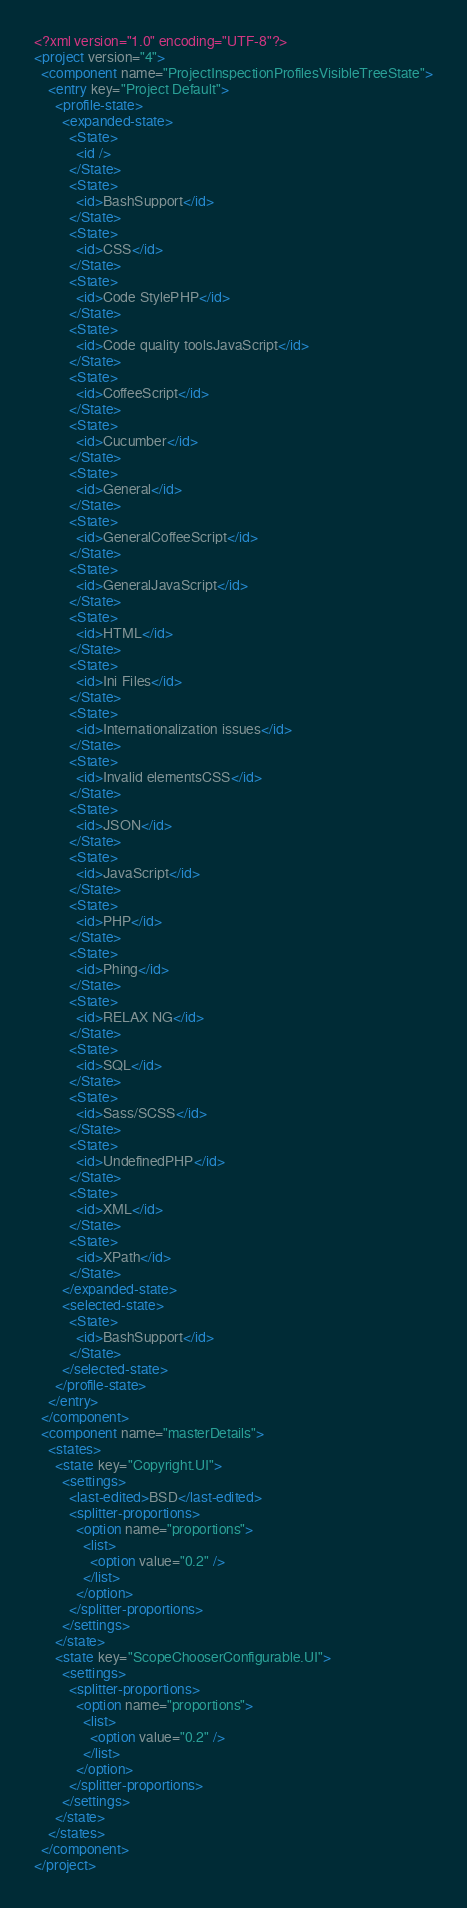Convert code to text. <code><loc_0><loc_0><loc_500><loc_500><_XML_><?xml version="1.0" encoding="UTF-8"?>
<project version="4">
  <component name="ProjectInspectionProfilesVisibleTreeState">
    <entry key="Project Default">
      <profile-state>
        <expanded-state>
          <State>
            <id />
          </State>
          <State>
            <id>BashSupport</id>
          </State>
          <State>
            <id>CSS</id>
          </State>
          <State>
            <id>Code StylePHP</id>
          </State>
          <State>
            <id>Code quality toolsJavaScript</id>
          </State>
          <State>
            <id>CoffeeScript</id>
          </State>
          <State>
            <id>Cucumber</id>
          </State>
          <State>
            <id>General</id>
          </State>
          <State>
            <id>GeneralCoffeeScript</id>
          </State>
          <State>
            <id>GeneralJavaScript</id>
          </State>
          <State>
            <id>HTML</id>
          </State>
          <State>
            <id>Ini Files</id>
          </State>
          <State>
            <id>Internationalization issues</id>
          </State>
          <State>
            <id>Invalid elementsCSS</id>
          </State>
          <State>
            <id>JSON</id>
          </State>
          <State>
            <id>JavaScript</id>
          </State>
          <State>
            <id>PHP</id>
          </State>
          <State>
            <id>Phing</id>
          </State>
          <State>
            <id>RELAX NG</id>
          </State>
          <State>
            <id>SQL</id>
          </State>
          <State>
            <id>Sass/SCSS</id>
          </State>
          <State>
            <id>UndefinedPHP</id>
          </State>
          <State>
            <id>XML</id>
          </State>
          <State>
            <id>XPath</id>
          </State>
        </expanded-state>
        <selected-state>
          <State>
            <id>BashSupport</id>
          </State>
        </selected-state>
      </profile-state>
    </entry>
  </component>
  <component name="masterDetails">
    <states>
      <state key="Copyright.UI">
        <settings>
          <last-edited>BSD</last-edited>
          <splitter-proportions>
            <option name="proportions">
              <list>
                <option value="0.2" />
              </list>
            </option>
          </splitter-proportions>
        </settings>
      </state>
      <state key="ScopeChooserConfigurable.UI">
        <settings>
          <splitter-proportions>
            <option name="proportions">
              <list>
                <option value="0.2" />
              </list>
            </option>
          </splitter-proportions>
        </settings>
      </state>
    </states>
  </component>
</project></code> 